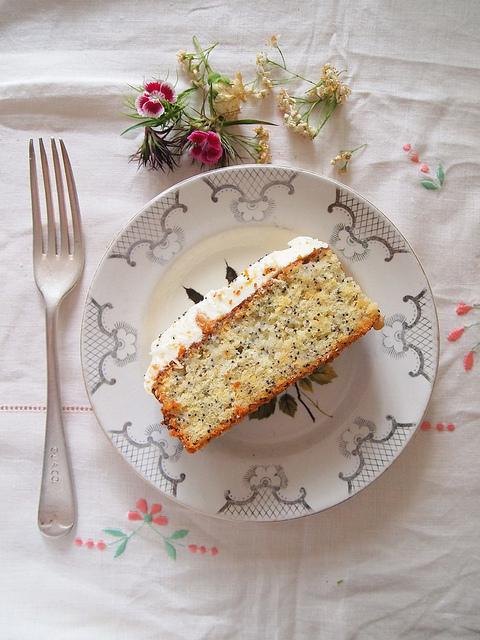How many slices have been cut?
Answer briefly. 1. What design are the plates?
Give a very brief answer. Round. Where is the cake?
Keep it brief. On plate. What utensil is shown in this picture?
Concise answer only. Fork. What is on the dish?
Answer briefly. Cake. How many forks do you see?
Be succinct. 1. 